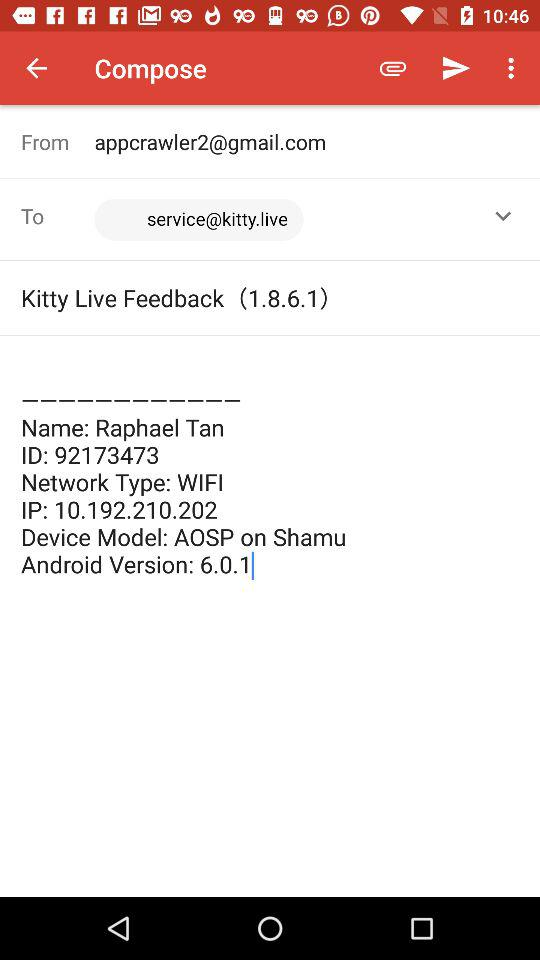What is the version? The version is 6.0.1. 